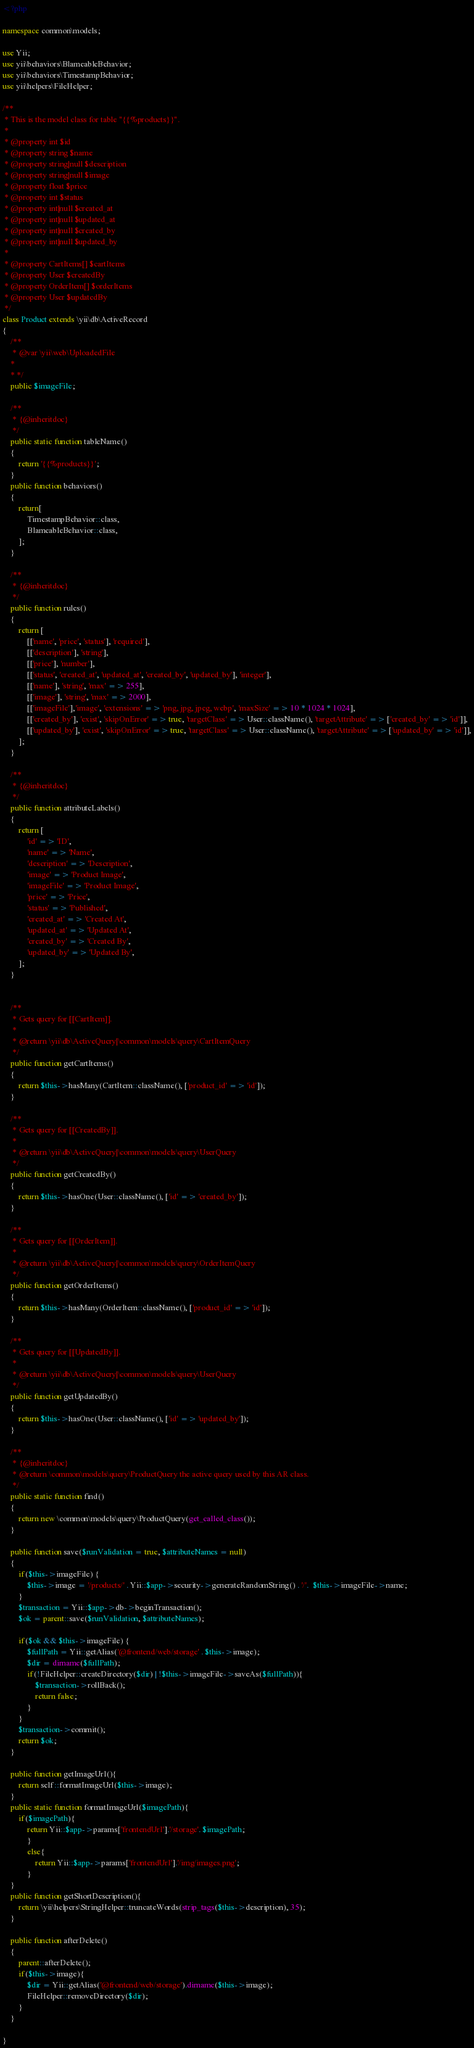<code> <loc_0><loc_0><loc_500><loc_500><_PHP_><?php

namespace common\models;

use Yii;
use yii\behaviors\BlameableBehavior;
use yii\behaviors\TimestampBehavior;
use yii\helpers\FileHelper;

/**
 * This is the model class for table "{{%products}}".
 *
 * @property int $id
 * @property string $name
 * @property string|null $description
 * @property string|null $image
 * @property float $price
 * @property int $status
 * @property int|null $created_at
 * @property int|null $updated_at
 * @property int|null $created_by
 * @property int|null $updated_by
 *
 * @property CartItems[] $cartItems
 * @property User $createdBy
 * @property OrderItem[] $orderItems
 * @property User $updatedBy
 */
class Product extends \yii\db\ActiveRecord
{
    /**
     * @var \yii\web\UploadedFile
    *
    * */
    public $imageFile;

    /**
     * {@inheritdoc}
     */
    public static function tableName()
    {
        return '{{%products}}';
    }
    public function behaviors()
    {
        return[
            TimestampBehavior::class,
            BlameableBehavior::class,   
        ];
    }

    /**
     * {@inheritdoc}
     */
    public function rules()
    {
        return [
            [['name', 'price', 'status'], 'required'],
            [['description'], 'string'],
            [['price'], 'number'],
            [['status', 'created_at', 'updated_at', 'created_by', 'updated_by'], 'integer'],
            [['name'], 'string', 'max' => 255],
            [['image'], 'string', 'max' => 2000],
            [['imageFile'],'image', 'extensions' => 'png, jpg, jpeg, webp', 'maxSize' => 10 * 1024 * 1024],
            [['created_by'], 'exist', 'skipOnError' => true, 'targetClass' => User::className(), 'targetAttribute' => ['created_by' => 'id']],
            [['updated_by'], 'exist', 'skipOnError' => true, 'targetClass' => User::className(), 'targetAttribute' => ['updated_by' => 'id']],
        ];
    }

    /**
     * {@inheritdoc}
     */
    public function attributeLabels()
    {
        return [
            'id' => 'ID',
            'name' => 'Name',
            'description' => 'Description',
            'image' => 'Product Image',
            'imageFile' => 'Product Image',
            'price' => 'Price',
            'status' => 'Published',
            'created_at' => 'Created At',
            'updated_at' => 'Updated At',
            'created_by' => 'Created By',
            'updated_by' => 'Updated By',
        ];
    }
    

    /**
     * Gets query for [[CartItem]].
     *
     * @return \yii\db\ActiveQuery|\common\models\query\CartItemQuery
     */
    public function getCartItems()
    {
        return $this->hasMany(CartItem::className(), ['product_id' => 'id']);
    }

    /**
     * Gets query for [[CreatedBy]].
     *
     * @return \yii\db\ActiveQuery|\common\models\query\UserQuery
     */
    public function getCreatedBy()
    {
        return $this->hasOne(User::className(), ['id' => 'created_by']);
    }

    /**
     * Gets query for [[OrderItem]].
     *
     * @return \yii\db\ActiveQuery|\common\models\query\OrderItemQuery
     */
    public function getOrderItems()
    {
        return $this->hasMany(OrderItem::className(), ['product_id' => 'id']);
    }

    /**
     * Gets query for [[UpdatedBy]].
     *
     * @return \yii\db\ActiveQuery|\common\models\query\UserQuery
     */
    public function getUpdatedBy()
    {
        return $this->hasOne(User::className(), ['id' => 'updated_by']);
    }

    /**
     * {@inheritdoc}
     * @return \common\models\query\ProductQuery the active query used by this AR class.
     */
    public static function find()
    {
        return new \common\models\query\ProductQuery(get_called_class());
    }

    public function save($runValidation = true, $attributeNames = null)
    {
        if($this->imageFile) {
            $this->image = '/products/' . Yii::$app->security->generateRandomString() . '/'.  $this->imageFile->name;
        }
        $transaction = Yii::$app->db->beginTransaction();
        $ok = parent::save($runValidation, $attributeNames);

        if($ok && $this->imageFile) {
            $fullPath = Yii::getAlias('@frontend/web/storage' . $this->image);
            $dir = dirname($fullPath);
            if(!FileHelper::createDirectory($dir) | !$this->imageFile->saveAs($fullPath)){
                $transaction->rollBack();
                return false;
            }
        }
        $transaction->commit();
        return $ok;
    }

    public function getImageUrl(){
        return self::formatImageUrl($this->image);
    }
    public static function formatImageUrl($imagePath){
        if($imagePath){
            return Yii::$app->params['frontendUrl'].'/storage'. $imagePath;
            }
            else{
                return Yii::$app->params['frontendUrl'].'/img/images.png';
            }
    }
    public function getShortDescription(){
        return \yii\helpers\StringHelper::truncateWords(strip_tags($this->description), 35); 
    }

    public function afterDelete()
    {
        parent::afterDelete();
        if($this->image){
            $dir = Yii::getAlias('@frontend/web/storage').dirname($this->image);
            FileHelper::removeDirectory($dir);
        }
    }
     
}</code> 